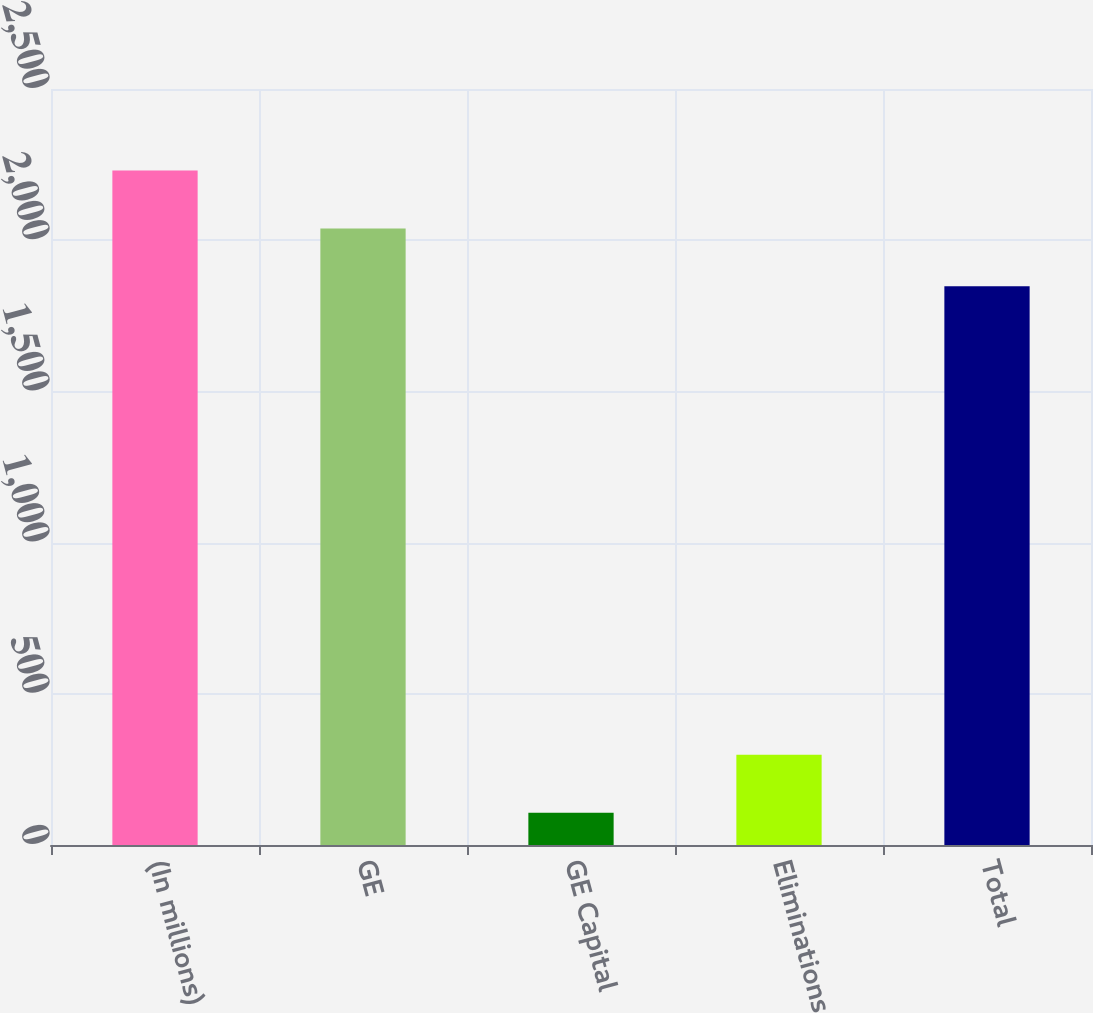<chart> <loc_0><loc_0><loc_500><loc_500><bar_chart><fcel>(In millions)<fcel>GE<fcel>GE Capital<fcel>Eliminations<fcel>Total<nl><fcel>2230.2<fcel>2039.1<fcel>107<fcel>298.1<fcel>1848<nl></chart> 